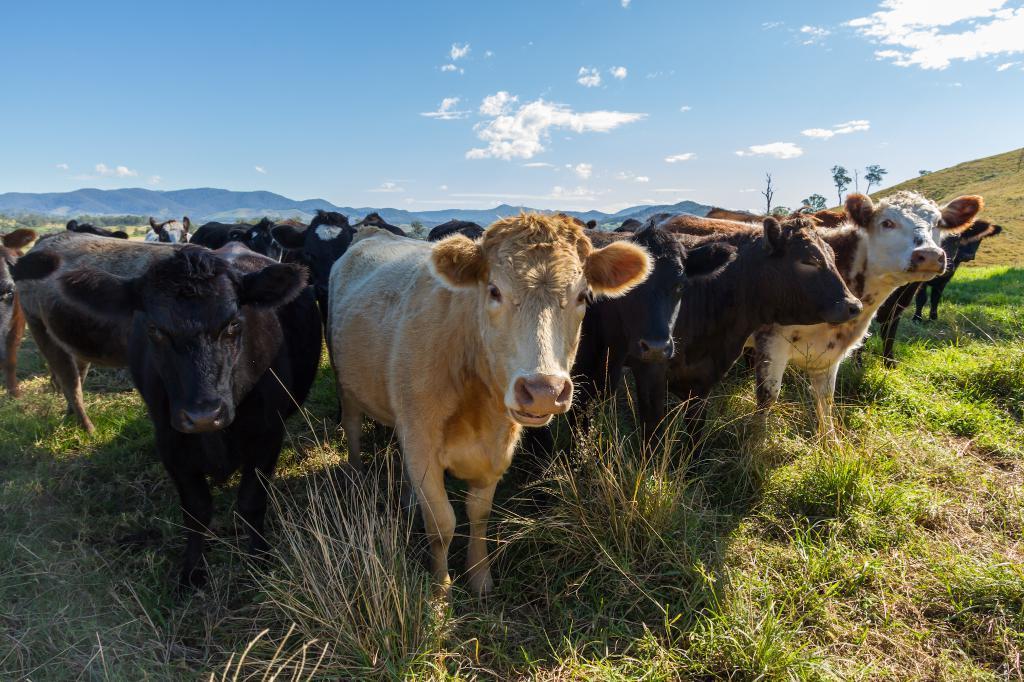How would you summarize this image in a sentence or two? In this picture we can see a group of cows on grass, trees, mountains and in the background we can see the sky with clouds. 